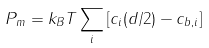<formula> <loc_0><loc_0><loc_500><loc_500>P _ { m } = k _ { B } T \sum _ { i } \left [ c _ { i } ( d / 2 ) - c _ { b , i } \right ]</formula> 